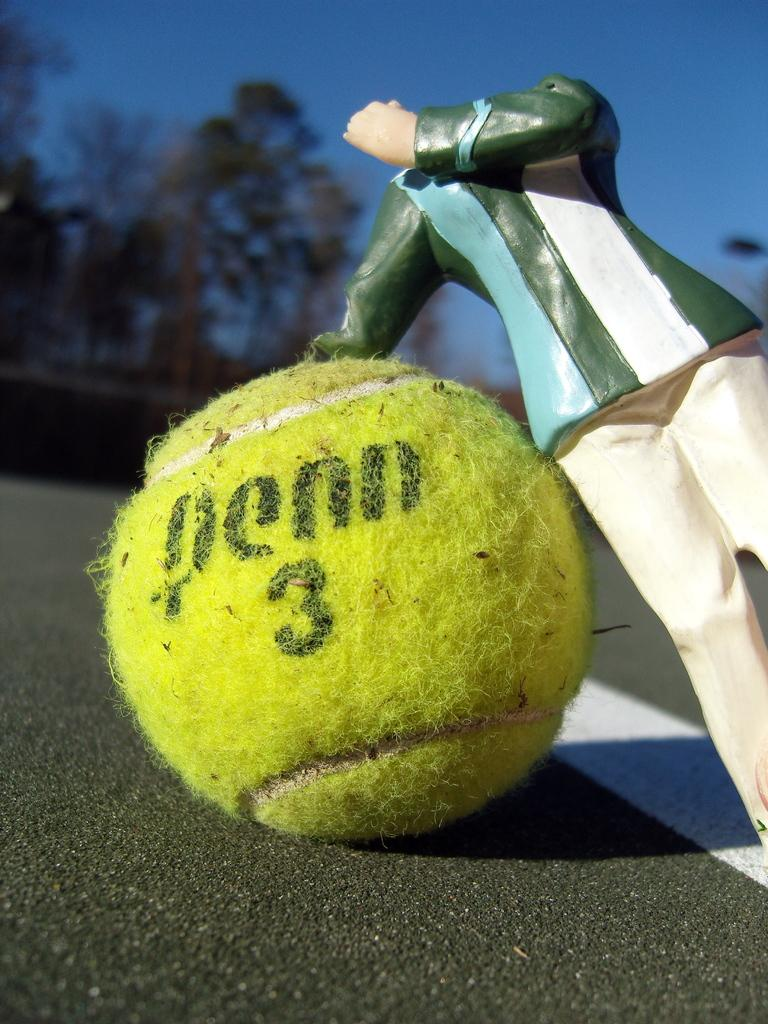<image>
Describe the image concisely. A doll leans over onto a soiled Penn 3 tennis ball. 